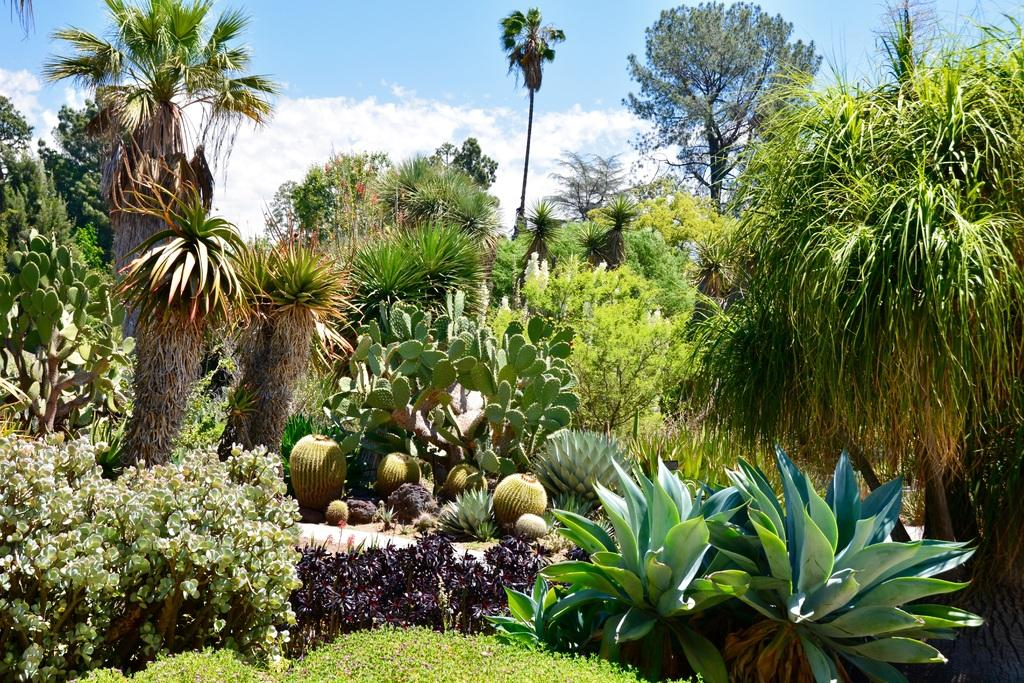What type of vegetation is present in the image? There are plants and trees in the image. What can be seen in the sky in the image? There are clouds visible in the image. What is the condition of the plantation in the image? There is no plantation present in the image, as it only features individual plants and trees. Can you tell me how many times the person sneezes in the image? There is no person present in the image, and therefore no sneezing can be observed. 